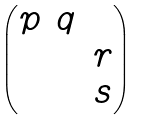Convert formula to latex. <formula><loc_0><loc_0><loc_500><loc_500>\begin{pmatrix} p & q & \\ & & r \\ & & s \end{pmatrix}</formula> 